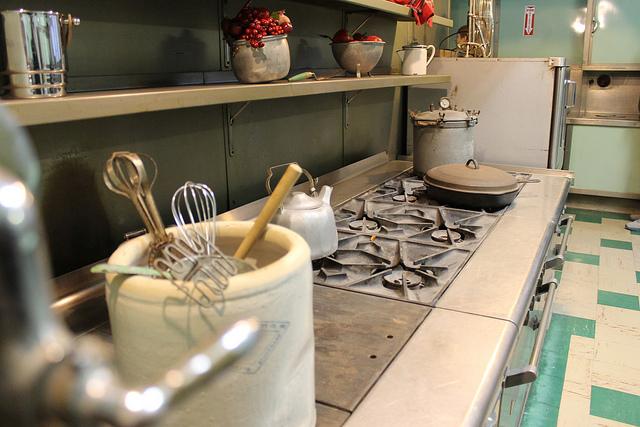What color are the cabinets?
Short answer required. Green. Where is the kettle?
Short answer required. Stove. Does the pan look dirty?
Be succinct. No. 